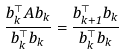<formula> <loc_0><loc_0><loc_500><loc_500>\frac { b _ { k } ^ { \top } A b _ { k } } { b _ { k } ^ { \top } b _ { k } } = \frac { b _ { k + 1 } ^ { \top } b _ { k } } { b _ { k } ^ { \top } b _ { k } }</formula> 